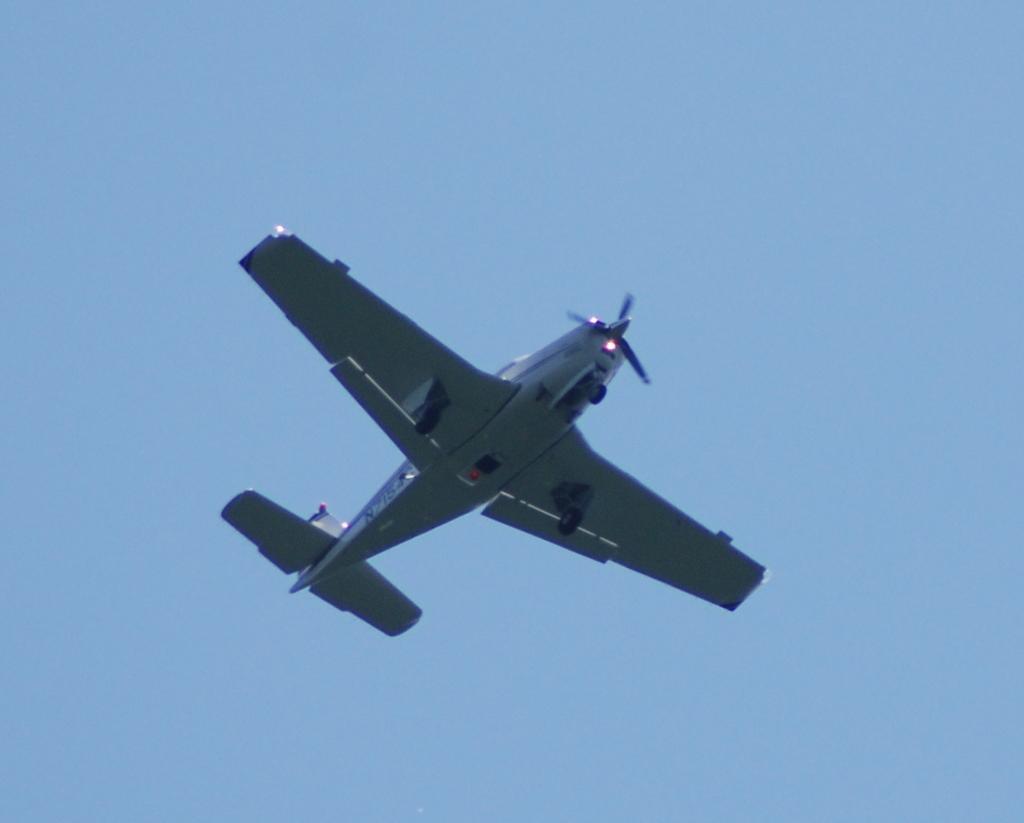Please provide a concise description of this image. In this image in the center there is an airplane, and in the background the sky. 